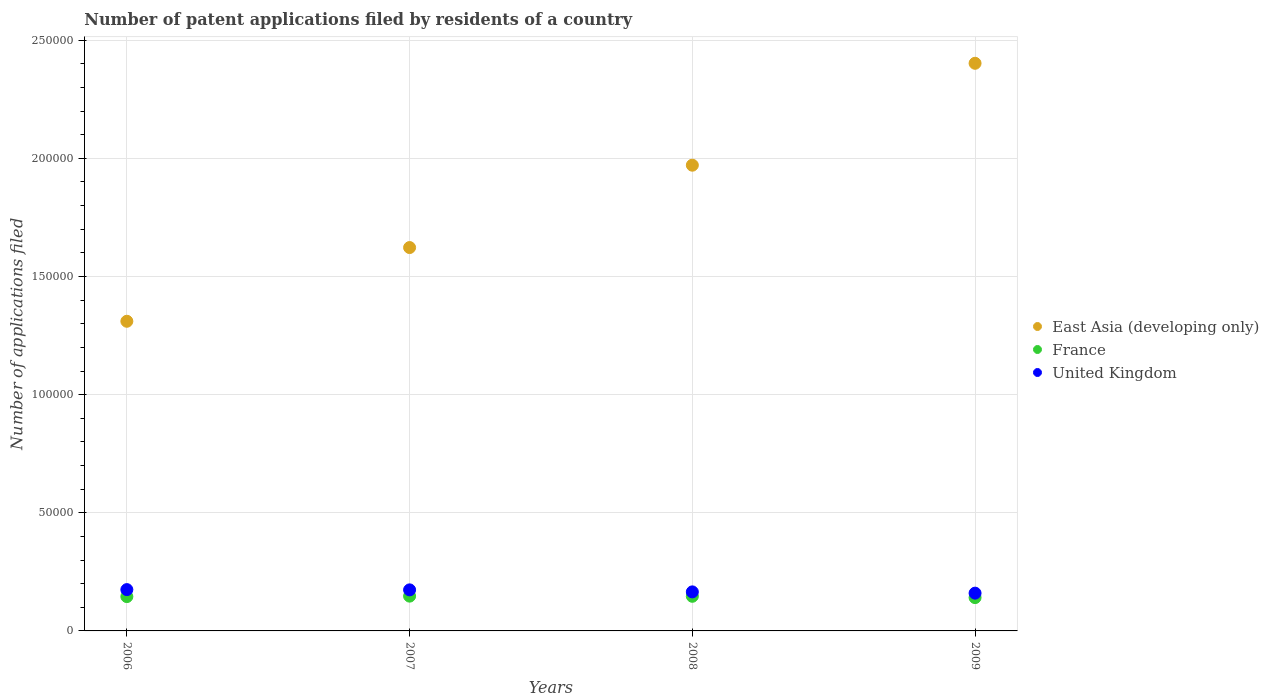How many different coloured dotlines are there?
Your answer should be very brief. 3. Is the number of dotlines equal to the number of legend labels?
Make the answer very short. Yes. What is the number of applications filed in East Asia (developing only) in 2008?
Provide a succinct answer. 1.97e+05. Across all years, what is the maximum number of applications filed in France?
Provide a short and direct response. 1.47e+04. Across all years, what is the minimum number of applications filed in East Asia (developing only)?
Your answer should be very brief. 1.31e+05. In which year was the number of applications filed in East Asia (developing only) maximum?
Your response must be concise. 2009. What is the total number of applications filed in United Kingdom in the graph?
Offer a very short reply. 6.74e+04. What is the difference between the number of applications filed in East Asia (developing only) in 2006 and that in 2008?
Your answer should be compact. -6.61e+04. What is the difference between the number of applications filed in United Kingdom in 2009 and the number of applications filed in East Asia (developing only) in 2008?
Keep it short and to the point. -1.81e+05. What is the average number of applications filed in United Kingdom per year?
Offer a terse response. 1.68e+04. In the year 2009, what is the difference between the number of applications filed in East Asia (developing only) and number of applications filed in France?
Provide a succinct answer. 2.26e+05. What is the ratio of the number of applications filed in United Kingdom in 2007 to that in 2009?
Keep it short and to the point. 1.09. Is the number of applications filed in France in 2008 less than that in 2009?
Your response must be concise. No. What is the difference between the highest and the second highest number of applications filed in United Kingdom?
Your answer should be compact. 109. What is the difference between the highest and the lowest number of applications filed in East Asia (developing only)?
Your answer should be very brief. 1.09e+05. In how many years, is the number of applications filed in United Kingdom greater than the average number of applications filed in United Kingdom taken over all years?
Ensure brevity in your answer.  2. Is the sum of the number of applications filed in United Kingdom in 2006 and 2009 greater than the maximum number of applications filed in France across all years?
Make the answer very short. Yes. Is the number of applications filed in East Asia (developing only) strictly less than the number of applications filed in United Kingdom over the years?
Offer a terse response. No. What is the difference between two consecutive major ticks on the Y-axis?
Your answer should be compact. 5.00e+04. Are the values on the major ticks of Y-axis written in scientific E-notation?
Your answer should be compact. No. Does the graph contain grids?
Offer a terse response. Yes. What is the title of the graph?
Offer a very short reply. Number of patent applications filed by residents of a country. What is the label or title of the X-axis?
Provide a short and direct response. Years. What is the label or title of the Y-axis?
Offer a very short reply. Number of applications filed. What is the Number of applications filed of East Asia (developing only) in 2006?
Provide a short and direct response. 1.31e+05. What is the Number of applications filed of France in 2006?
Give a very brief answer. 1.45e+04. What is the Number of applications filed of United Kingdom in 2006?
Give a very brief answer. 1.75e+04. What is the Number of applications filed in East Asia (developing only) in 2007?
Provide a short and direct response. 1.62e+05. What is the Number of applications filed of France in 2007?
Keep it short and to the point. 1.47e+04. What is the Number of applications filed in United Kingdom in 2007?
Ensure brevity in your answer.  1.74e+04. What is the Number of applications filed in East Asia (developing only) in 2008?
Ensure brevity in your answer.  1.97e+05. What is the Number of applications filed in France in 2008?
Your answer should be very brief. 1.47e+04. What is the Number of applications filed of United Kingdom in 2008?
Make the answer very short. 1.65e+04. What is the Number of applications filed of East Asia (developing only) in 2009?
Offer a very short reply. 2.40e+05. What is the Number of applications filed of France in 2009?
Ensure brevity in your answer.  1.41e+04. What is the Number of applications filed of United Kingdom in 2009?
Your response must be concise. 1.60e+04. Across all years, what is the maximum Number of applications filed in East Asia (developing only)?
Ensure brevity in your answer.  2.40e+05. Across all years, what is the maximum Number of applications filed of France?
Offer a terse response. 1.47e+04. Across all years, what is the maximum Number of applications filed of United Kingdom?
Provide a short and direct response. 1.75e+04. Across all years, what is the minimum Number of applications filed in East Asia (developing only)?
Your response must be concise. 1.31e+05. Across all years, what is the minimum Number of applications filed of France?
Offer a terse response. 1.41e+04. Across all years, what is the minimum Number of applications filed in United Kingdom?
Make the answer very short. 1.60e+04. What is the total Number of applications filed of East Asia (developing only) in the graph?
Offer a very short reply. 7.31e+05. What is the total Number of applications filed of France in the graph?
Your answer should be very brief. 5.80e+04. What is the total Number of applications filed in United Kingdom in the graph?
Ensure brevity in your answer.  6.74e+04. What is the difference between the Number of applications filed of East Asia (developing only) in 2006 and that in 2007?
Ensure brevity in your answer.  -3.12e+04. What is the difference between the Number of applications filed in France in 2006 and that in 2007?
Ensure brevity in your answer.  -193. What is the difference between the Number of applications filed of United Kingdom in 2006 and that in 2007?
Offer a very short reply. 109. What is the difference between the Number of applications filed of East Asia (developing only) in 2006 and that in 2008?
Give a very brief answer. -6.61e+04. What is the difference between the Number of applications filed in France in 2006 and that in 2008?
Provide a short and direct response. -129. What is the difference between the Number of applications filed of United Kingdom in 2006 and that in 2008?
Your answer should be compact. 961. What is the difference between the Number of applications filed of East Asia (developing only) in 2006 and that in 2009?
Ensure brevity in your answer.  -1.09e+05. What is the difference between the Number of applications filed in France in 2006 and that in 2009?
Make the answer very short. 429. What is the difference between the Number of applications filed of United Kingdom in 2006 and that in 2009?
Your response must be concise. 1499. What is the difference between the Number of applications filed in East Asia (developing only) in 2007 and that in 2008?
Give a very brief answer. -3.49e+04. What is the difference between the Number of applications filed in France in 2007 and that in 2008?
Offer a very short reply. 64. What is the difference between the Number of applications filed of United Kingdom in 2007 and that in 2008?
Provide a succinct answer. 852. What is the difference between the Number of applications filed in East Asia (developing only) in 2007 and that in 2009?
Your answer should be compact. -7.80e+04. What is the difference between the Number of applications filed in France in 2007 and that in 2009?
Make the answer very short. 622. What is the difference between the Number of applications filed of United Kingdom in 2007 and that in 2009?
Offer a very short reply. 1390. What is the difference between the Number of applications filed in East Asia (developing only) in 2008 and that in 2009?
Ensure brevity in your answer.  -4.31e+04. What is the difference between the Number of applications filed in France in 2008 and that in 2009?
Offer a terse response. 558. What is the difference between the Number of applications filed of United Kingdom in 2008 and that in 2009?
Make the answer very short. 538. What is the difference between the Number of applications filed of East Asia (developing only) in 2006 and the Number of applications filed of France in 2007?
Make the answer very short. 1.16e+05. What is the difference between the Number of applications filed in East Asia (developing only) in 2006 and the Number of applications filed in United Kingdom in 2007?
Make the answer very short. 1.14e+05. What is the difference between the Number of applications filed of France in 2006 and the Number of applications filed of United Kingdom in 2007?
Offer a terse response. -2846. What is the difference between the Number of applications filed in East Asia (developing only) in 2006 and the Number of applications filed in France in 2008?
Make the answer very short. 1.16e+05. What is the difference between the Number of applications filed in East Asia (developing only) in 2006 and the Number of applications filed in United Kingdom in 2008?
Ensure brevity in your answer.  1.15e+05. What is the difference between the Number of applications filed in France in 2006 and the Number of applications filed in United Kingdom in 2008?
Give a very brief answer. -1994. What is the difference between the Number of applications filed of East Asia (developing only) in 2006 and the Number of applications filed of France in 2009?
Offer a very short reply. 1.17e+05. What is the difference between the Number of applications filed of East Asia (developing only) in 2006 and the Number of applications filed of United Kingdom in 2009?
Your response must be concise. 1.15e+05. What is the difference between the Number of applications filed of France in 2006 and the Number of applications filed of United Kingdom in 2009?
Offer a terse response. -1456. What is the difference between the Number of applications filed of East Asia (developing only) in 2007 and the Number of applications filed of France in 2008?
Give a very brief answer. 1.48e+05. What is the difference between the Number of applications filed of East Asia (developing only) in 2007 and the Number of applications filed of United Kingdom in 2008?
Make the answer very short. 1.46e+05. What is the difference between the Number of applications filed in France in 2007 and the Number of applications filed in United Kingdom in 2008?
Make the answer very short. -1801. What is the difference between the Number of applications filed in East Asia (developing only) in 2007 and the Number of applications filed in France in 2009?
Offer a very short reply. 1.48e+05. What is the difference between the Number of applications filed of East Asia (developing only) in 2007 and the Number of applications filed of United Kingdom in 2009?
Offer a terse response. 1.46e+05. What is the difference between the Number of applications filed in France in 2007 and the Number of applications filed in United Kingdom in 2009?
Ensure brevity in your answer.  -1263. What is the difference between the Number of applications filed in East Asia (developing only) in 2008 and the Number of applications filed in France in 2009?
Keep it short and to the point. 1.83e+05. What is the difference between the Number of applications filed of East Asia (developing only) in 2008 and the Number of applications filed of United Kingdom in 2009?
Your answer should be very brief. 1.81e+05. What is the difference between the Number of applications filed of France in 2008 and the Number of applications filed of United Kingdom in 2009?
Offer a terse response. -1327. What is the average Number of applications filed in East Asia (developing only) per year?
Provide a short and direct response. 1.83e+05. What is the average Number of applications filed of France per year?
Your answer should be compact. 1.45e+04. What is the average Number of applications filed of United Kingdom per year?
Offer a very short reply. 1.68e+04. In the year 2006, what is the difference between the Number of applications filed in East Asia (developing only) and Number of applications filed in France?
Your response must be concise. 1.17e+05. In the year 2006, what is the difference between the Number of applications filed of East Asia (developing only) and Number of applications filed of United Kingdom?
Ensure brevity in your answer.  1.14e+05. In the year 2006, what is the difference between the Number of applications filed of France and Number of applications filed of United Kingdom?
Provide a succinct answer. -2955. In the year 2007, what is the difference between the Number of applications filed of East Asia (developing only) and Number of applications filed of France?
Your response must be concise. 1.48e+05. In the year 2007, what is the difference between the Number of applications filed in East Asia (developing only) and Number of applications filed in United Kingdom?
Keep it short and to the point. 1.45e+05. In the year 2007, what is the difference between the Number of applications filed in France and Number of applications filed in United Kingdom?
Make the answer very short. -2653. In the year 2008, what is the difference between the Number of applications filed in East Asia (developing only) and Number of applications filed in France?
Offer a terse response. 1.82e+05. In the year 2008, what is the difference between the Number of applications filed in East Asia (developing only) and Number of applications filed in United Kingdom?
Your answer should be compact. 1.81e+05. In the year 2008, what is the difference between the Number of applications filed in France and Number of applications filed in United Kingdom?
Make the answer very short. -1865. In the year 2009, what is the difference between the Number of applications filed of East Asia (developing only) and Number of applications filed of France?
Offer a very short reply. 2.26e+05. In the year 2009, what is the difference between the Number of applications filed of East Asia (developing only) and Number of applications filed of United Kingdom?
Keep it short and to the point. 2.24e+05. In the year 2009, what is the difference between the Number of applications filed of France and Number of applications filed of United Kingdom?
Your response must be concise. -1885. What is the ratio of the Number of applications filed of East Asia (developing only) in 2006 to that in 2007?
Provide a short and direct response. 0.81. What is the ratio of the Number of applications filed of France in 2006 to that in 2007?
Offer a terse response. 0.99. What is the ratio of the Number of applications filed in East Asia (developing only) in 2006 to that in 2008?
Make the answer very short. 0.66. What is the ratio of the Number of applications filed of United Kingdom in 2006 to that in 2008?
Give a very brief answer. 1.06. What is the ratio of the Number of applications filed in East Asia (developing only) in 2006 to that in 2009?
Your answer should be very brief. 0.55. What is the ratio of the Number of applications filed in France in 2006 to that in 2009?
Ensure brevity in your answer.  1.03. What is the ratio of the Number of applications filed of United Kingdom in 2006 to that in 2009?
Offer a terse response. 1.09. What is the ratio of the Number of applications filed of East Asia (developing only) in 2007 to that in 2008?
Keep it short and to the point. 0.82. What is the ratio of the Number of applications filed in United Kingdom in 2007 to that in 2008?
Offer a very short reply. 1.05. What is the ratio of the Number of applications filed in East Asia (developing only) in 2007 to that in 2009?
Provide a succinct answer. 0.68. What is the ratio of the Number of applications filed in France in 2007 to that in 2009?
Provide a short and direct response. 1.04. What is the ratio of the Number of applications filed of United Kingdom in 2007 to that in 2009?
Provide a succinct answer. 1.09. What is the ratio of the Number of applications filed in East Asia (developing only) in 2008 to that in 2009?
Give a very brief answer. 0.82. What is the ratio of the Number of applications filed of France in 2008 to that in 2009?
Ensure brevity in your answer.  1.04. What is the ratio of the Number of applications filed of United Kingdom in 2008 to that in 2009?
Offer a terse response. 1.03. What is the difference between the highest and the second highest Number of applications filed in East Asia (developing only)?
Your answer should be very brief. 4.31e+04. What is the difference between the highest and the second highest Number of applications filed in France?
Your answer should be very brief. 64. What is the difference between the highest and the second highest Number of applications filed of United Kingdom?
Ensure brevity in your answer.  109. What is the difference between the highest and the lowest Number of applications filed of East Asia (developing only)?
Offer a very short reply. 1.09e+05. What is the difference between the highest and the lowest Number of applications filed in France?
Give a very brief answer. 622. What is the difference between the highest and the lowest Number of applications filed of United Kingdom?
Offer a terse response. 1499. 